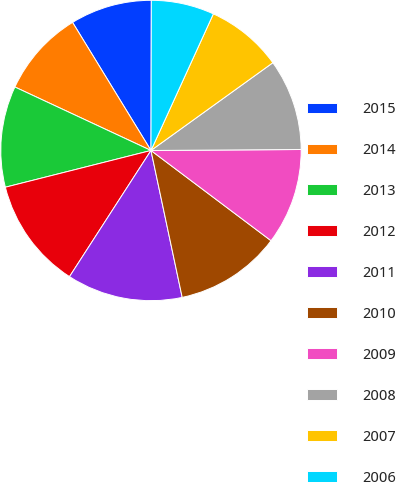Convert chart to OTSL. <chart><loc_0><loc_0><loc_500><loc_500><pie_chart><fcel>2015<fcel>2014<fcel>2013<fcel>2012<fcel>2011<fcel>2010<fcel>2009<fcel>2008<fcel>2007<fcel>2006<nl><fcel>8.78%<fcel>9.31%<fcel>10.88%<fcel>11.94%<fcel>12.46%<fcel>11.41%<fcel>10.36%<fcel>9.83%<fcel>8.25%<fcel>6.78%<nl></chart> 